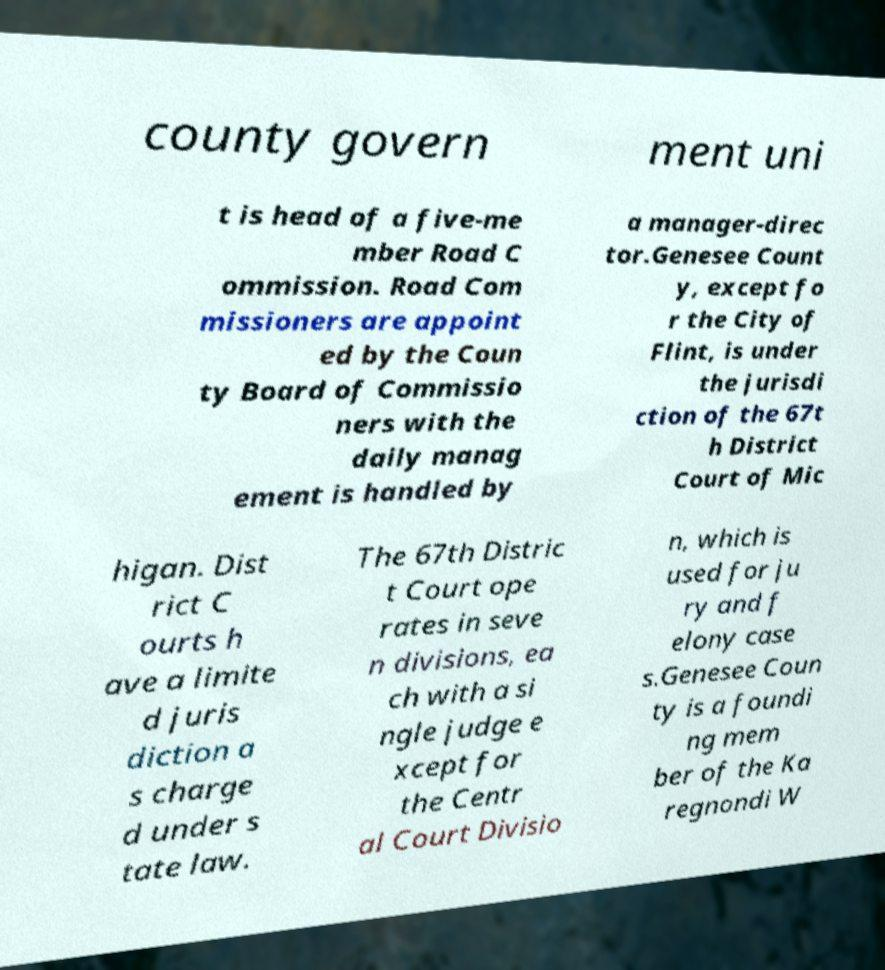Please identify and transcribe the text found in this image. county govern ment uni t is head of a five-me mber Road C ommission. Road Com missioners are appoint ed by the Coun ty Board of Commissio ners with the daily manag ement is handled by a manager-direc tor.Genesee Count y, except fo r the City of Flint, is under the jurisdi ction of the 67t h District Court of Mic higan. Dist rict C ourts h ave a limite d juris diction a s charge d under s tate law. The 67th Distric t Court ope rates in seve n divisions, ea ch with a si ngle judge e xcept for the Centr al Court Divisio n, which is used for ju ry and f elony case s.Genesee Coun ty is a foundi ng mem ber of the Ka regnondi W 